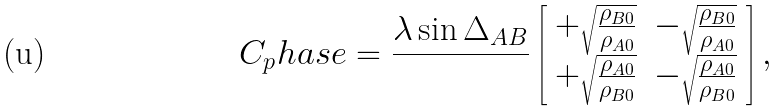Convert formula to latex. <formula><loc_0><loc_0><loc_500><loc_500>C _ { p } h a s e = \frac { \lambda \sin \Delta _ { A B } } { } \left [ \begin{array} { c c } + \sqrt { \frac { \rho _ { B 0 } } { \rho _ { A 0 } } } & - \sqrt { \frac { \rho _ { B 0 } } { \rho _ { A 0 } } } \\ + \sqrt { \frac { \rho _ { A 0 } } { \rho _ { B 0 } } } & - \sqrt { \frac { \rho _ { A 0 } } { \rho _ { B 0 } } } \\ \end{array} \right ] ,</formula> 